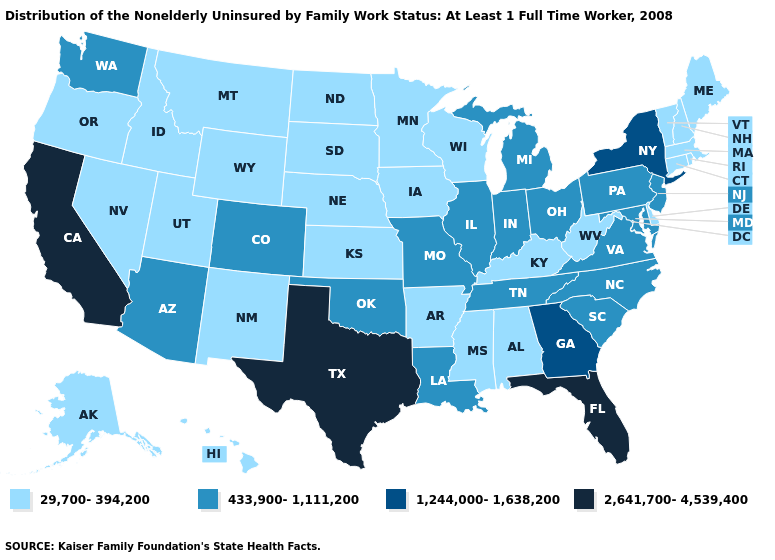Which states have the highest value in the USA?
Concise answer only. California, Florida, Texas. Name the states that have a value in the range 433,900-1,111,200?
Quick response, please. Arizona, Colorado, Illinois, Indiana, Louisiana, Maryland, Michigan, Missouri, New Jersey, North Carolina, Ohio, Oklahoma, Pennsylvania, South Carolina, Tennessee, Virginia, Washington. Among the states that border Colorado , which have the lowest value?
Be succinct. Kansas, Nebraska, New Mexico, Utah, Wyoming. What is the value of Nebraska?
Give a very brief answer. 29,700-394,200. Name the states that have a value in the range 433,900-1,111,200?
Write a very short answer. Arizona, Colorado, Illinois, Indiana, Louisiana, Maryland, Michigan, Missouri, New Jersey, North Carolina, Ohio, Oklahoma, Pennsylvania, South Carolina, Tennessee, Virginia, Washington. Does Arkansas have the highest value in the South?
Write a very short answer. No. Does the map have missing data?
Short answer required. No. What is the lowest value in the USA?
Be succinct. 29,700-394,200. Which states hav the highest value in the South?
Keep it brief. Florida, Texas. Name the states that have a value in the range 29,700-394,200?
Concise answer only. Alabama, Alaska, Arkansas, Connecticut, Delaware, Hawaii, Idaho, Iowa, Kansas, Kentucky, Maine, Massachusetts, Minnesota, Mississippi, Montana, Nebraska, Nevada, New Hampshire, New Mexico, North Dakota, Oregon, Rhode Island, South Dakota, Utah, Vermont, West Virginia, Wisconsin, Wyoming. Does New Hampshire have the same value as Connecticut?
Quick response, please. Yes. What is the value of Montana?
Quick response, please. 29,700-394,200. What is the value of Wisconsin?
Answer briefly. 29,700-394,200. Does the first symbol in the legend represent the smallest category?
Quick response, please. Yes. 